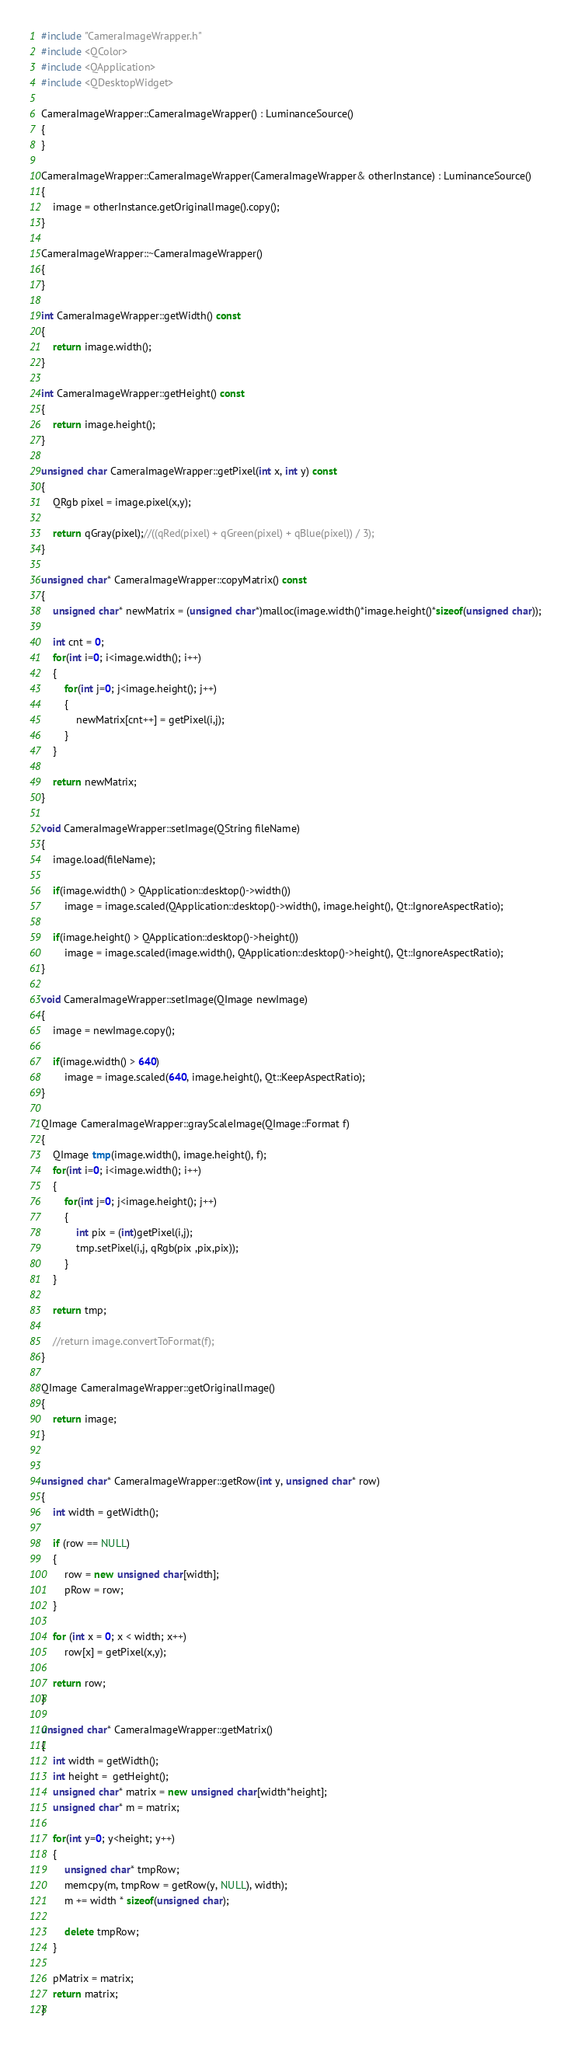Convert code to text. <code><loc_0><loc_0><loc_500><loc_500><_C++_>#include "CameraImageWrapper.h"
#include <QColor>
#include <QApplication>
#include <QDesktopWidget>

CameraImageWrapper::CameraImageWrapper() : LuminanceSource()
{
}

CameraImageWrapper::CameraImageWrapper(CameraImageWrapper& otherInstance) : LuminanceSource()
{
    image = otherInstance.getOriginalImage().copy();
}

CameraImageWrapper::~CameraImageWrapper()
{
}

int CameraImageWrapper::getWidth() const
{
    return image.width();
}

int CameraImageWrapper::getHeight() const
{
    return image.height();
}

unsigned char CameraImageWrapper::getPixel(int x, int y) const
{
    QRgb pixel = image.pixel(x,y);

    return qGray(pixel);//((qRed(pixel) + qGreen(pixel) + qBlue(pixel)) / 3);
}

unsigned char* CameraImageWrapper::copyMatrix() const
{
    unsigned char* newMatrix = (unsigned char*)malloc(image.width()*image.height()*sizeof(unsigned char));

    int cnt = 0;
    for(int i=0; i<image.width(); i++)
    {
        for(int j=0; j<image.height(); j++)
        {
            newMatrix[cnt++] = getPixel(i,j);
        }
    }

    return newMatrix;
}

void CameraImageWrapper::setImage(QString fileName)
{
    image.load(fileName);

    if(image.width() > QApplication::desktop()->width())
        image = image.scaled(QApplication::desktop()->width(), image.height(), Qt::IgnoreAspectRatio);

    if(image.height() > QApplication::desktop()->height())
        image = image.scaled(image.width(), QApplication::desktop()->height(), Qt::IgnoreAspectRatio);
}

void CameraImageWrapper::setImage(QImage newImage)
{
    image = newImage.copy();

    if(image.width() > 640)
        image = image.scaled(640, image.height(), Qt::KeepAspectRatio);
}

QImage CameraImageWrapper::grayScaleImage(QImage::Format f)
{
    QImage tmp(image.width(), image.height(), f);
    for(int i=0; i<image.width(); i++)
    {
        for(int j=0; j<image.height(); j++)
        {
            int pix = (int)getPixel(i,j);
            tmp.setPixel(i,j, qRgb(pix ,pix,pix));
        }   
    }

    return tmp;

    //return image.convertToFormat(f);
}

QImage CameraImageWrapper::getOriginalImage()
{
    return image;
}


unsigned char* CameraImageWrapper::getRow(int y, unsigned char* row)
{
    int width = getWidth();

    if (row == NULL)
    {
        row = new unsigned char[width];
        pRow = row;
    }

    for (int x = 0; x < width; x++)
        row[x] = getPixel(x,y);

    return row;
}

unsigned char* CameraImageWrapper::getMatrix()
{
    int width = getWidth();
    int height =  getHeight();
    unsigned char* matrix = new unsigned char[width*height];
    unsigned char* m = matrix;

    for(int y=0; y<height; y++)
    {
        unsigned char* tmpRow;
        memcpy(m, tmpRow = getRow(y, NULL), width);
        m += width * sizeof(unsigned char);

        delete tmpRow;
    }

    pMatrix = matrix;
    return matrix;
}
</code> 